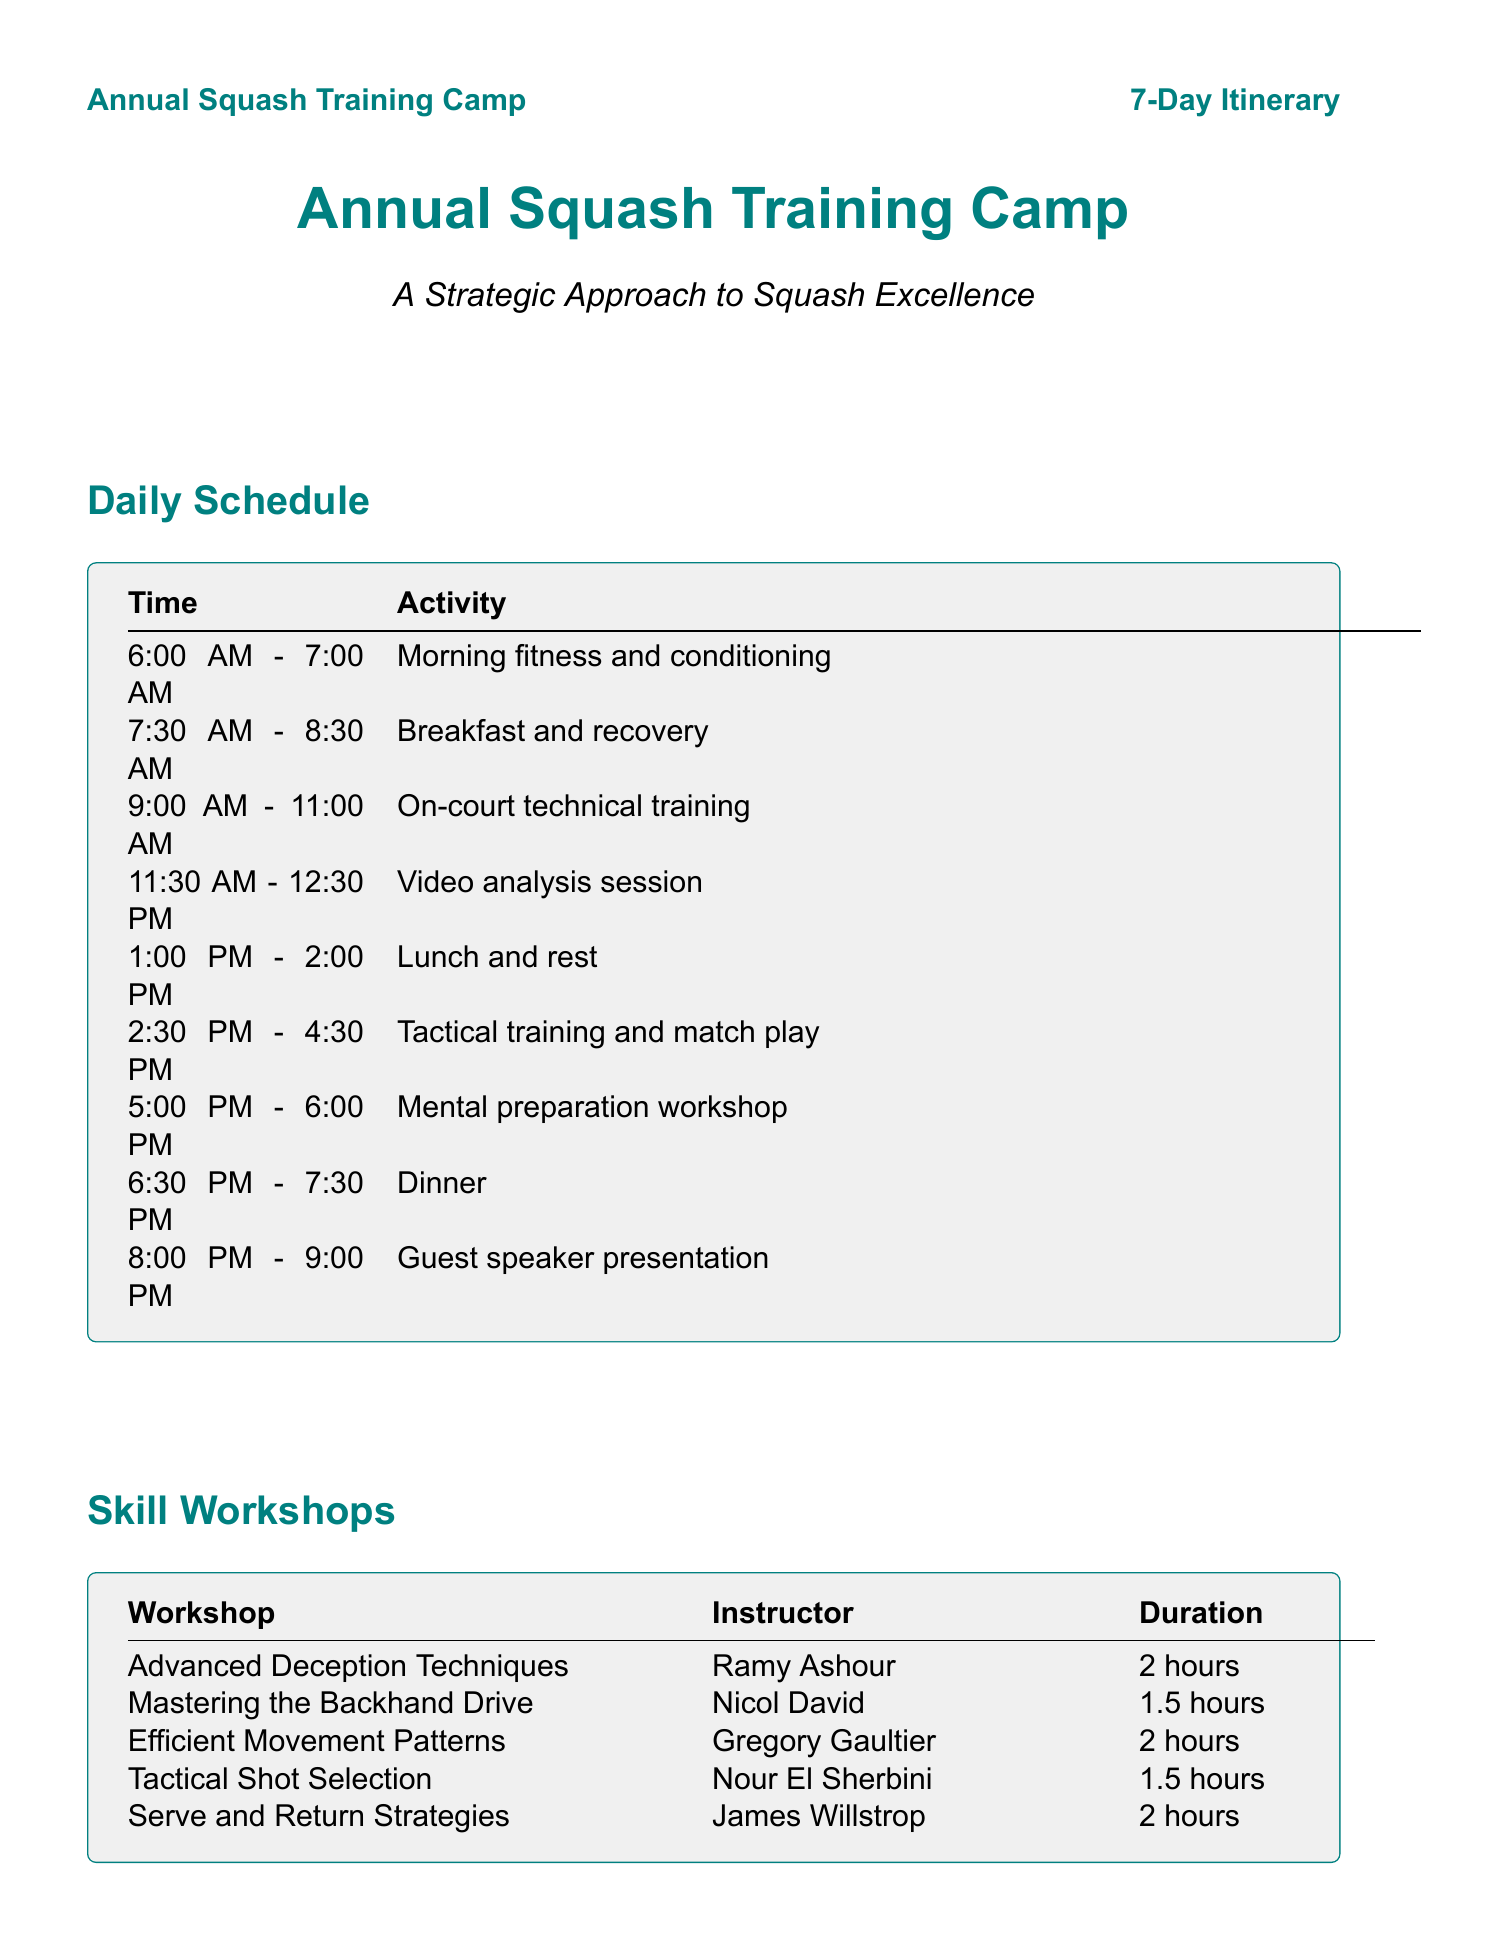What time does the morning fitness and conditioning start? The morning fitness and conditioning starts at 6:00 AM.
Answer: 6:00 AM Who leads the mental preparation workshop? The mental preparation workshop is led by a specific expert mentioned in the document, focusing on mental strategies.
Answer: Not specified What is one of the activities scheduled for Day 3 afternoon? The document outlines a special activity for Day 3 afternoon, which is related to team-building.
Answer: Team-building exercises How long is the 'Mastering the Backhand Drive' workshop? The duration of the workshop is listed, which provides specific training time.
Answer: 1.5 hours Which guest speaker discusses injury prevention? The guest speaker on this topic is identified by name and their associated topic is given in the document.
Answer: Dr. Philip Newton How many skill workshops are listed in the itinerary? The total number of skill workshops is explicitly mentioned in the count of workshops provided.
Answer: 5 What is the date of the mini-tournament? The date for the mini-tournament is included within the special activities section, highlighting this specific event.
Answer: Day 7 What equipment is required for the training camp? The document lists various required items for participants, providing specific details about gear needed.
Answer: At least two squash racquets Which instructor teaches 'Advanced Deception Techniques'? The specific person teaching this skill is noted within the skill workshops section of the document.
Answer: Ramy Ashour 